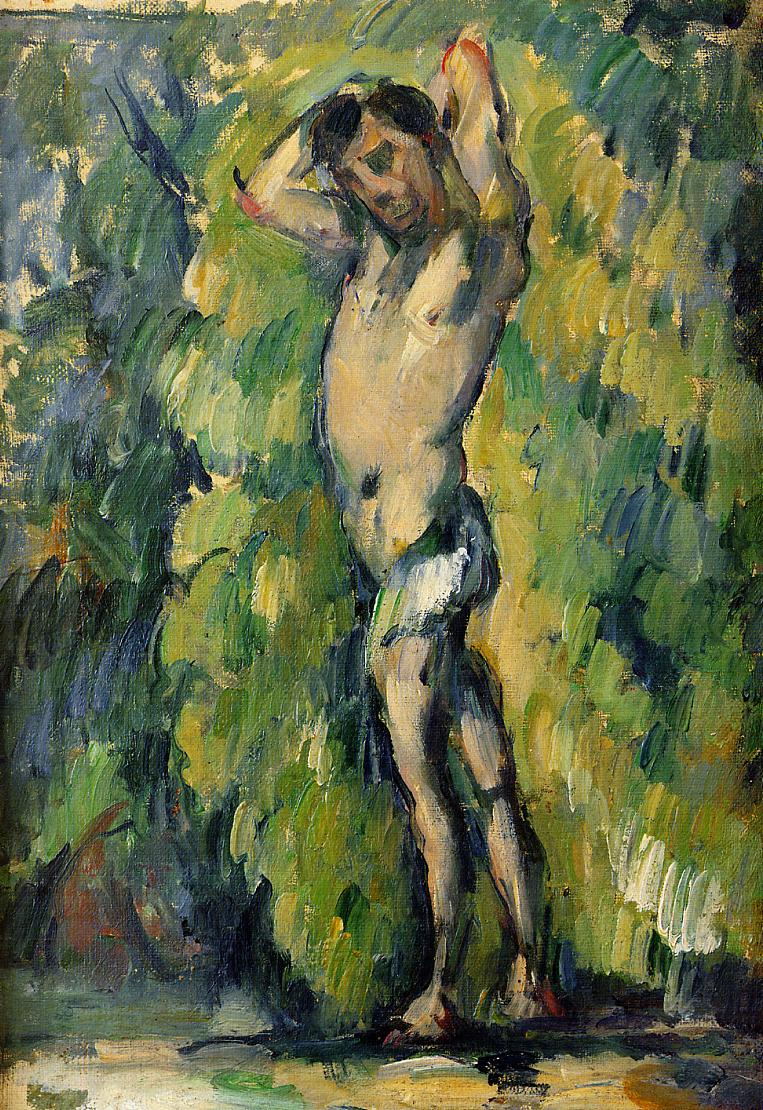Can you describe the mood or emotion that this painting evokes? This painting conveys a serene and contemplative mood. The loose, dynamic brushstrokes typical of the impressionist style create a sense of movement within the stillness of the forest, suggesting a fleeting moment captured in time. The open posture of the figure, combined with the surrounding vibrant yet soothing greens and blues, evokes feelings of freedom and tranquility, inviting the viewer to reflect on the beauty and transience of nature. 